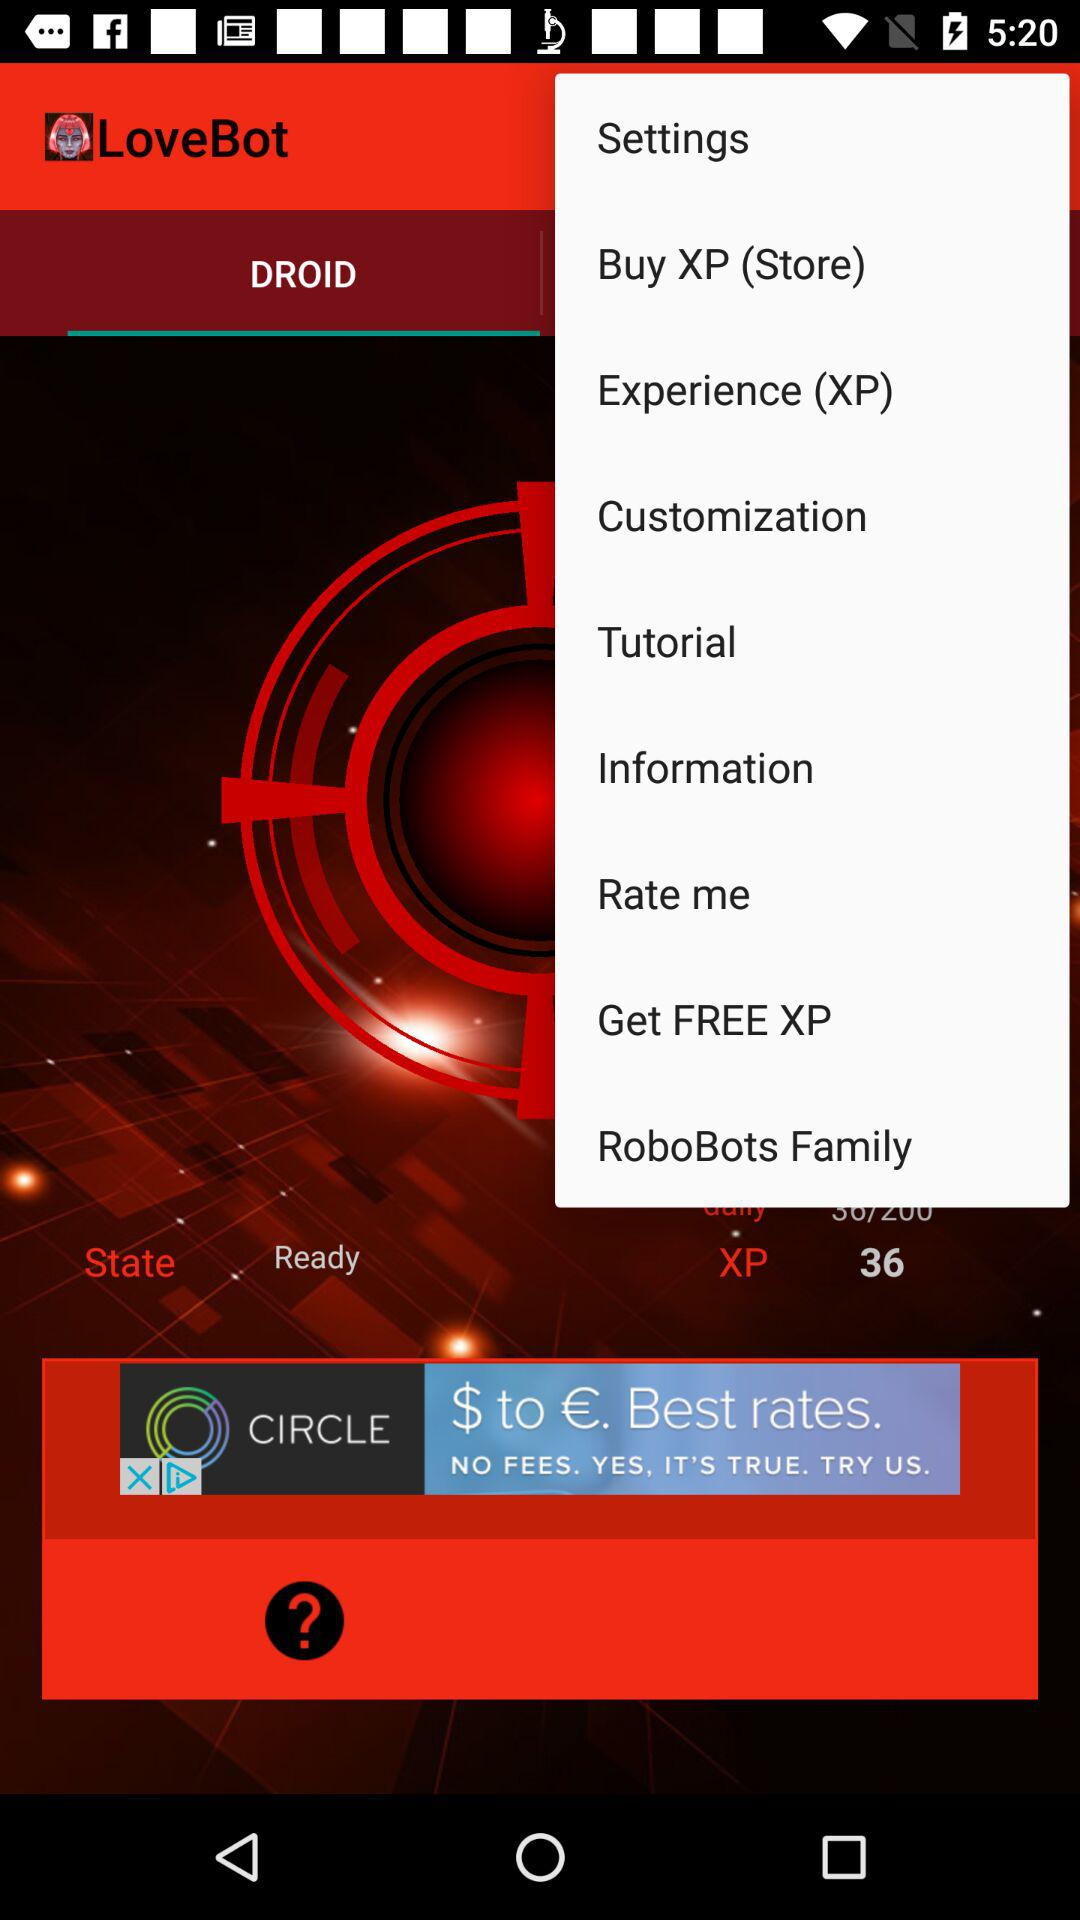Which tab has been selected? The selected tab is "DROID". 